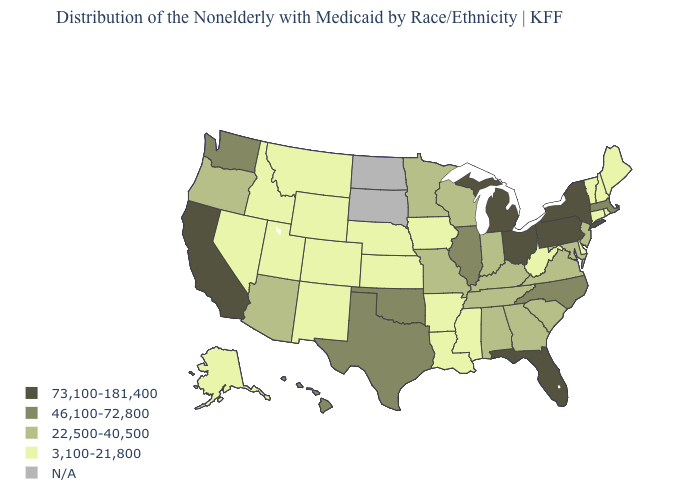What is the highest value in the South ?
Answer briefly. 73,100-181,400. Does the first symbol in the legend represent the smallest category?
Short answer required. No. What is the value of South Dakota?
Keep it brief. N/A. Which states have the lowest value in the USA?
Short answer required. Alaska, Arkansas, Colorado, Connecticut, Delaware, Idaho, Iowa, Kansas, Louisiana, Maine, Mississippi, Montana, Nebraska, Nevada, New Hampshire, New Mexico, Rhode Island, Utah, Vermont, West Virginia, Wyoming. What is the value of West Virginia?
Write a very short answer. 3,100-21,800. What is the highest value in states that border Kansas?
Answer briefly. 46,100-72,800. What is the value of Missouri?
Short answer required. 22,500-40,500. Name the states that have a value in the range 46,100-72,800?
Be succinct. Hawaii, Illinois, Massachusetts, North Carolina, Oklahoma, Texas, Washington. What is the value of Arkansas?
Concise answer only. 3,100-21,800. Is the legend a continuous bar?
Be succinct. No. Does the first symbol in the legend represent the smallest category?
Quick response, please. No. Which states have the highest value in the USA?
Write a very short answer. California, Florida, Michigan, New York, Ohio, Pennsylvania. 